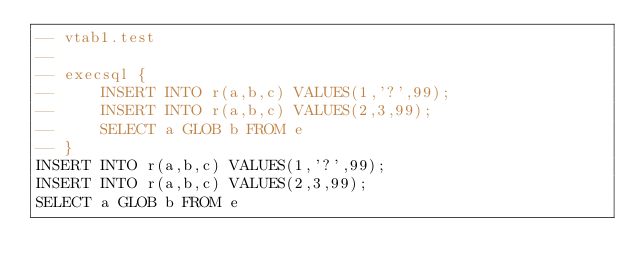<code> <loc_0><loc_0><loc_500><loc_500><_SQL_>-- vtab1.test
-- 
-- execsql {
--     INSERT INTO r(a,b,c) VALUES(1,'?',99);
--     INSERT INTO r(a,b,c) VALUES(2,3,99);
--     SELECT a GLOB b FROM e
-- }
INSERT INTO r(a,b,c) VALUES(1,'?',99);
INSERT INTO r(a,b,c) VALUES(2,3,99);
SELECT a GLOB b FROM e</code> 